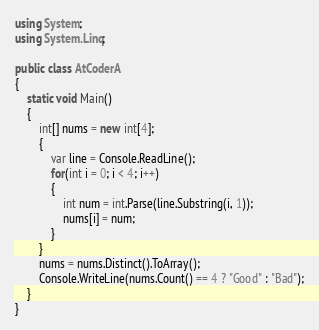<code> <loc_0><loc_0><loc_500><loc_500><_C#_>using System;
using System.Linq;

public class AtCoderA
{
    static void Main()
    {
        int[] nums = new int[4];
        {
            var line = Console.ReadLine();
            for(int i = 0; i < 4; i++)
            {
                int num = int.Parse(line.Substring(i, 1));
                nums[i] = num;
            }
        }
        nums = nums.Distinct().ToArray();
        Console.WriteLine(nums.Count() == 4 ? "Good" : "Bad");
    }
}</code> 